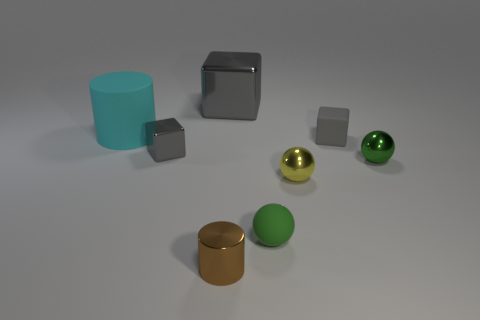Subtract all big metal cubes. How many cubes are left? 2 Add 1 large gray matte spheres. How many objects exist? 9 Subtract all yellow spheres. How many spheres are left? 2 Subtract 1 spheres. How many spheres are left? 2 Subtract all brown blocks. How many brown cylinders are left? 1 Subtract 0 blue balls. How many objects are left? 8 Subtract all cylinders. How many objects are left? 6 Subtract all blue spheres. Subtract all cyan blocks. How many spheres are left? 3 Subtract all small yellow metal spheres. Subtract all tiny green rubber balls. How many objects are left? 6 Add 7 brown metal cylinders. How many brown metal cylinders are left? 8 